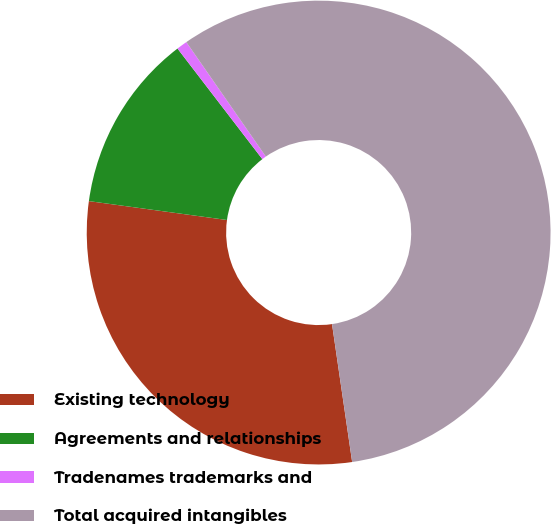Convert chart. <chart><loc_0><loc_0><loc_500><loc_500><pie_chart><fcel>Existing technology<fcel>Agreements and relationships<fcel>Tradenames trademarks and<fcel>Total acquired intangibles<nl><fcel>29.47%<fcel>12.42%<fcel>0.75%<fcel>57.35%<nl></chart> 